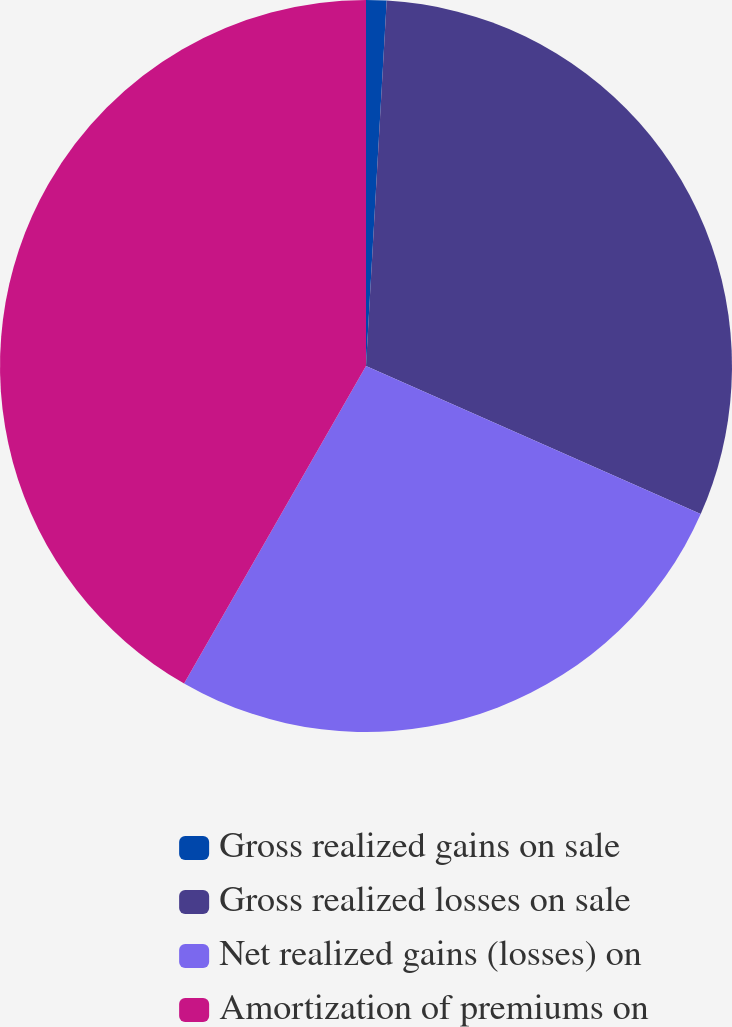Convert chart to OTSL. <chart><loc_0><loc_0><loc_500><loc_500><pie_chart><fcel>Gross realized gains on sale<fcel>Gross realized losses on sale<fcel>Net realized gains (losses) on<fcel>Amortization of premiums on<nl><fcel>0.9%<fcel>30.73%<fcel>26.65%<fcel>41.72%<nl></chart> 